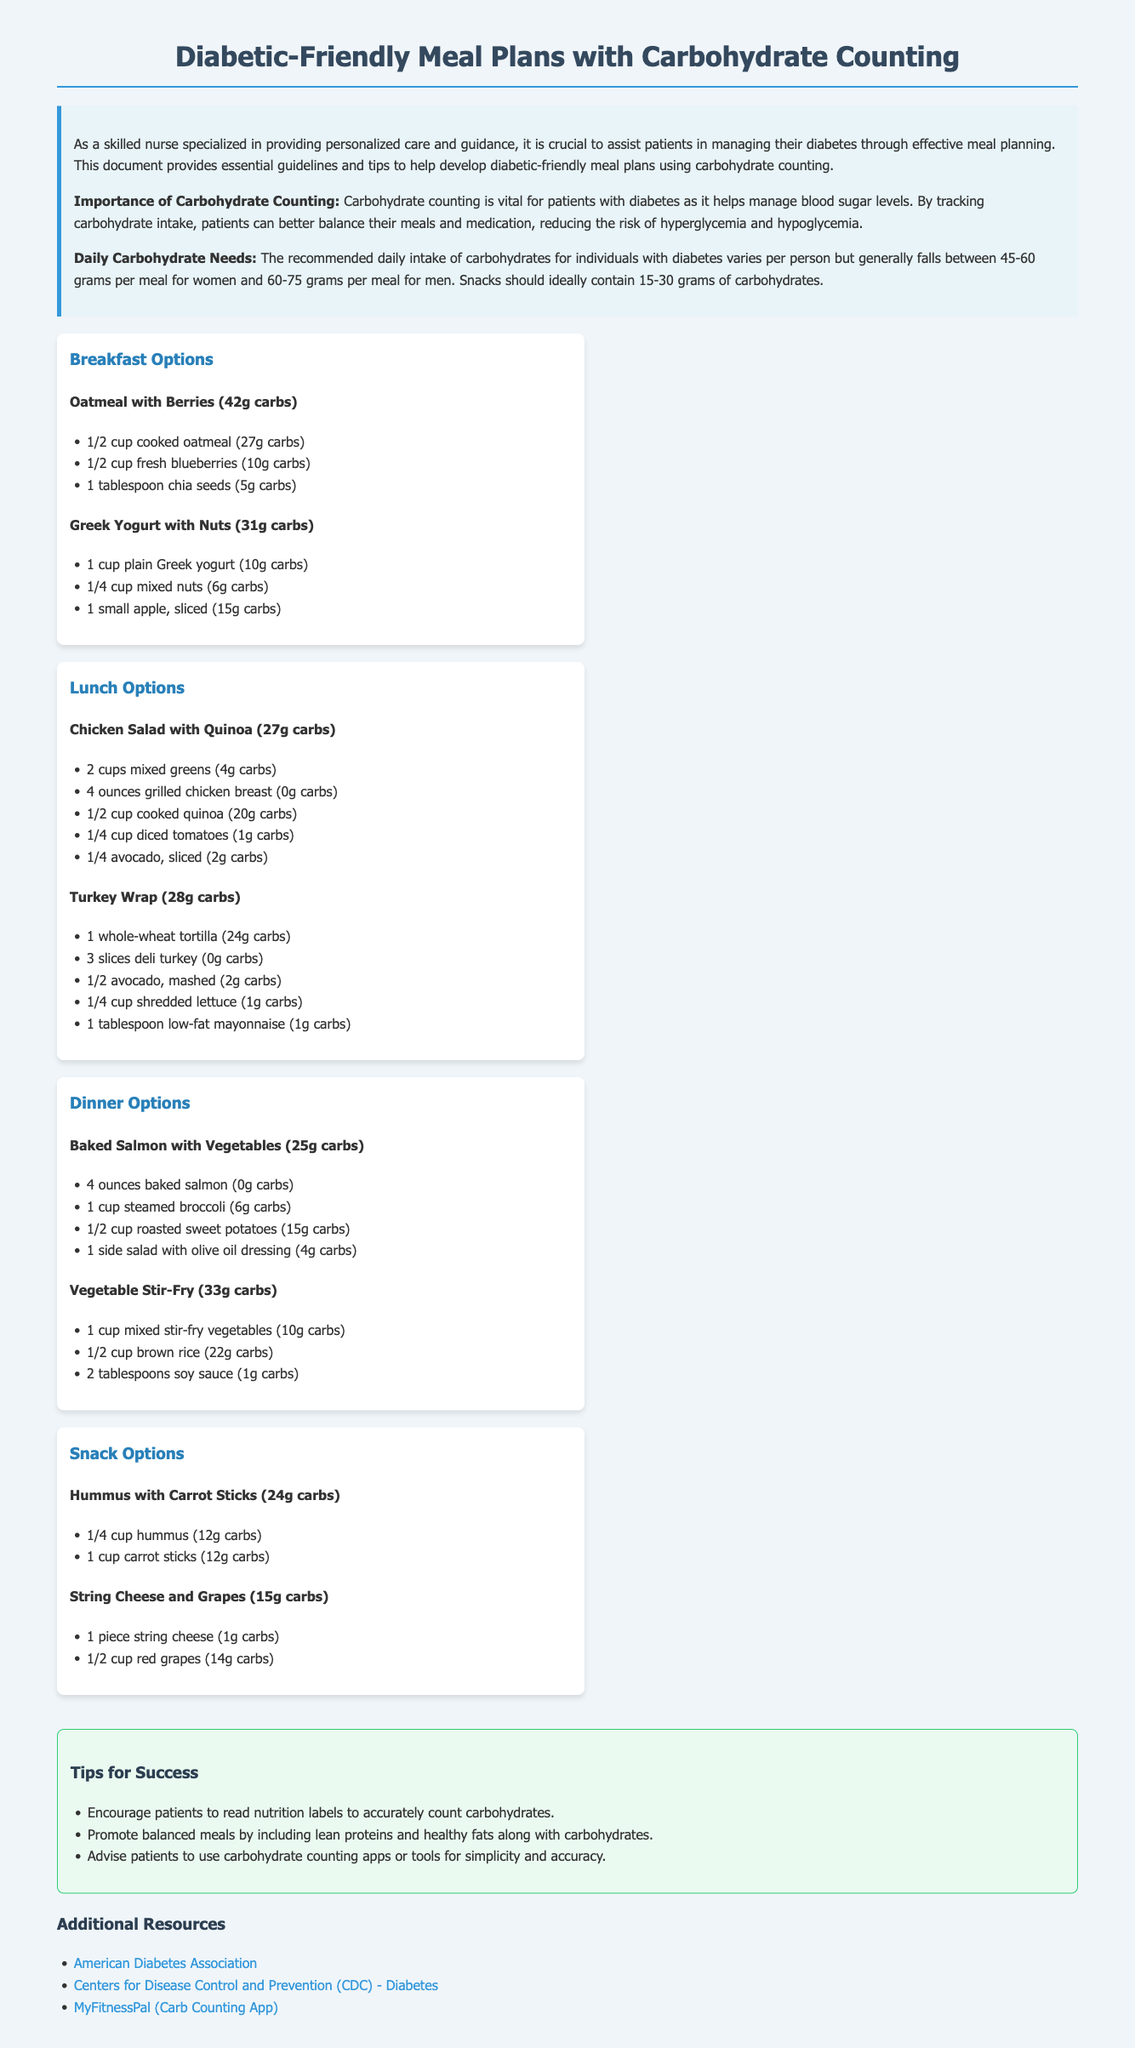what is the daily carbohydrate intake for women? The recommended daily intake of carbohydrates for women generally falls between 45-60 grams per meal.
Answer: 45-60 grams what is one breakfast option with 42 grams of carbohydrates? One breakfast option listed that contains 42 grams of carbohydrates is oatmeal with berries.
Answer: oatmeal with berries how many grams of carbohydrates are in the Turkish Wrap for lunch? The Turkey Wrap contains 28 grams of carbohydrates.
Answer: 28 grams what is the carbohydrate content of baked salmon with vegetables? Baked salmon with vegetables has a carbohydrate content of 25 grams.
Answer: 25 grams how many grams of carbohydrates are recommended per snack? Snacks should ideally contain 15-30 grams of carbohydrates.
Answer: 15-30 grams what type of meal plan does this document focus on? The document focuses on diabetic-friendly meal plans with carbohydrate counting.
Answer: diabetic-friendly which resource is recommended for carbohydrate counting? The MyFitnessPal app is recommended for carbohydrate counting.
Answer: MyFitnessPal how much quinoa is included in the chicken salad lunch option? The chicken salad lunch option includes 1/2 cup of cooked quinoa.
Answer: 1/2 cup what is the main goal of carbohydrate counting for diabetic patients? The main goal is to help manage blood sugar levels.
Answer: manage blood sugar levels 